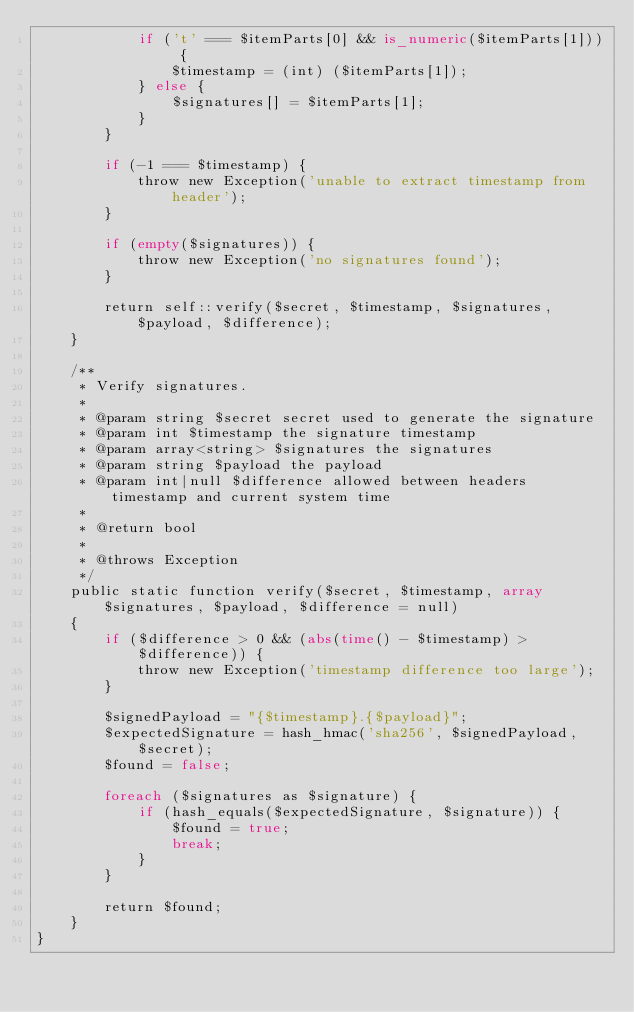<code> <loc_0><loc_0><loc_500><loc_500><_PHP_>            if ('t' === $itemParts[0] && is_numeric($itemParts[1])) {
                $timestamp = (int) ($itemParts[1]);
            } else {
                $signatures[] = $itemParts[1];
            }
        }

        if (-1 === $timestamp) {
            throw new Exception('unable to extract timestamp from header');
        }

        if (empty($signatures)) {
            throw new Exception('no signatures found');
        }

        return self::verify($secret, $timestamp, $signatures, $payload, $difference);
    }

    /**
     * Verify signatures.
     *
     * @param string $secret secret used to generate the signature
     * @param int $timestamp the signature timestamp
     * @param array<string> $signatures the signatures
     * @param string $payload the payload
     * @param int|null $difference allowed between headers timestamp and current system time
     *
     * @return bool
     *
     * @throws Exception
     */
    public static function verify($secret, $timestamp, array $signatures, $payload, $difference = null)
    {
        if ($difference > 0 && (abs(time() - $timestamp) > $difference)) {
            throw new Exception('timestamp difference too large');
        }

        $signedPayload = "{$timestamp}.{$payload}";
        $expectedSignature = hash_hmac('sha256', $signedPayload, $secret);
        $found = false;

        foreach ($signatures as $signature) {
            if (hash_equals($expectedSignature, $signature)) {
                $found = true;
                break;
            }
        }

        return $found;
    }
}
</code> 